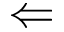<formula> <loc_0><loc_0><loc_500><loc_500>\Leftarrow</formula> 